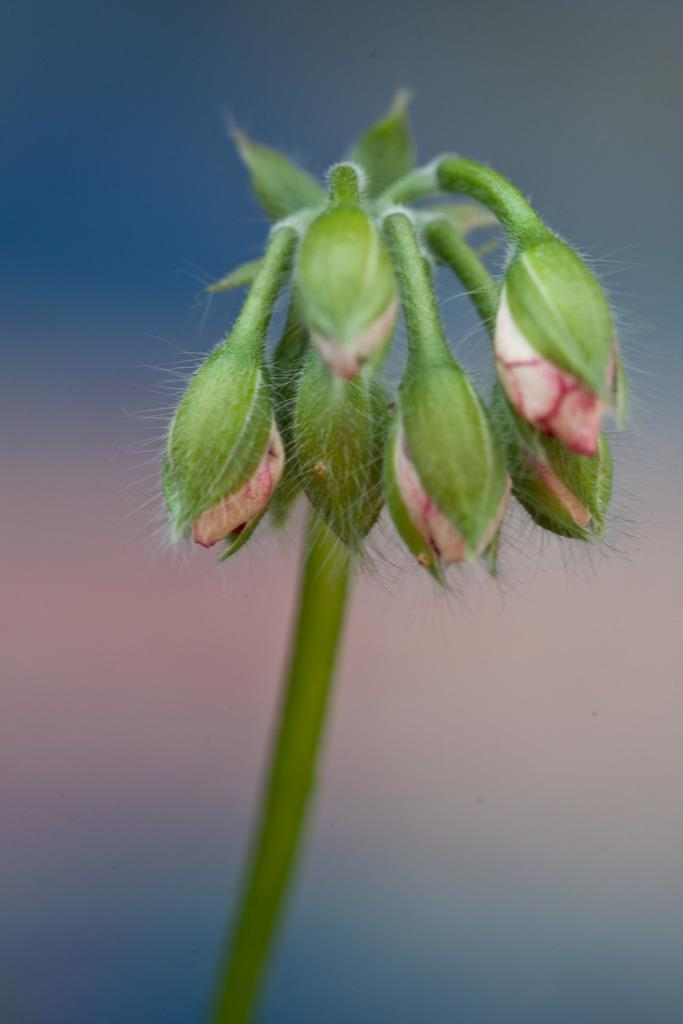What is present in the image? There is a plant in the image. Can you describe the plant in more detail? The plant has many flower buds. What can be observed about the background of the image? The background of the image is blurry. Where is the tub located in the image? There is no tub present in the image. Can you describe the harmony between the plant and the tramp in the image? There is no tramp present in the image, and the concept of harmony between the plant and a tramp is not applicable. 